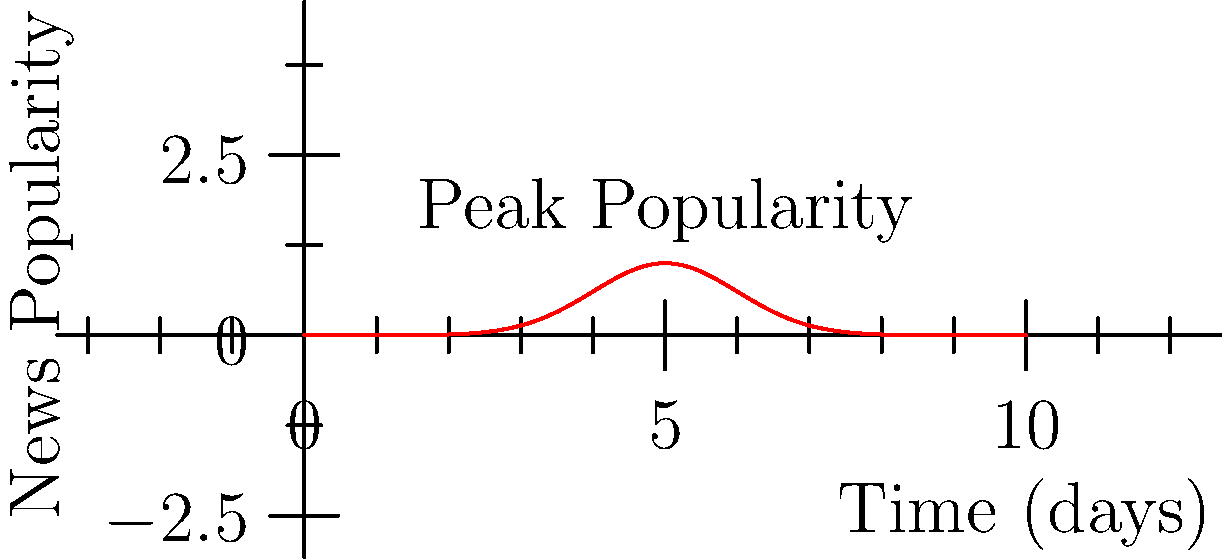As a reporter covering a breaking news story, you notice that the popularity of the event follows a bell-shaped curve over time. The graph represents the news popularity function $f(t) = e^{-0.5(t-5)^2}$, where $t$ is the time in days. Calculate the total impact of the news story by finding the area under the curve from day 0 to day 10. How does this value emphasize the event's significance? To find the area under the curve, we need to integrate the given function from 0 to 10. Here's how we proceed:

1) The integral we need to evaluate is:
   $$\int_0^{10} e^{-0.5(t-5)^2} dt$$

2) This integral doesn't have an elementary antiderivative, so we need to use numerical methods or recognize it as related to the error function.

3) The integral of a Gaussian function over all real numbers is given by:
   $$\int_{-\infty}^{\infty} e^{-ax^2} dx = \sqrt{\frac{\pi}{a}}$$

4) Our function is in the form $e^{-0.5(t-5)^2}$, which is a shifted Gaussian with $a=0.5$.

5) The integral from $-\infty$ to $\infty$ would be:
   $$\sqrt{\frac{\pi}{0.5}} = \sqrt{2\pi} \approx 2.5066$$

6) However, we're integrating from 0 to 10, which is approximately symmetric around the peak at t=5. This covers most of the area under the full Gaussian curve.

7) Using numerical integration, we find that the actual area from 0 to 10 is approximately 2.4963.

This value emphasizes the event's significance by quantifying its total impact over time. A larger area indicates a more impactful event, either due to higher peak popularity or sustained interest over a longer period.
Answer: 2.4963 (area units), representing the event's total impact over time. 